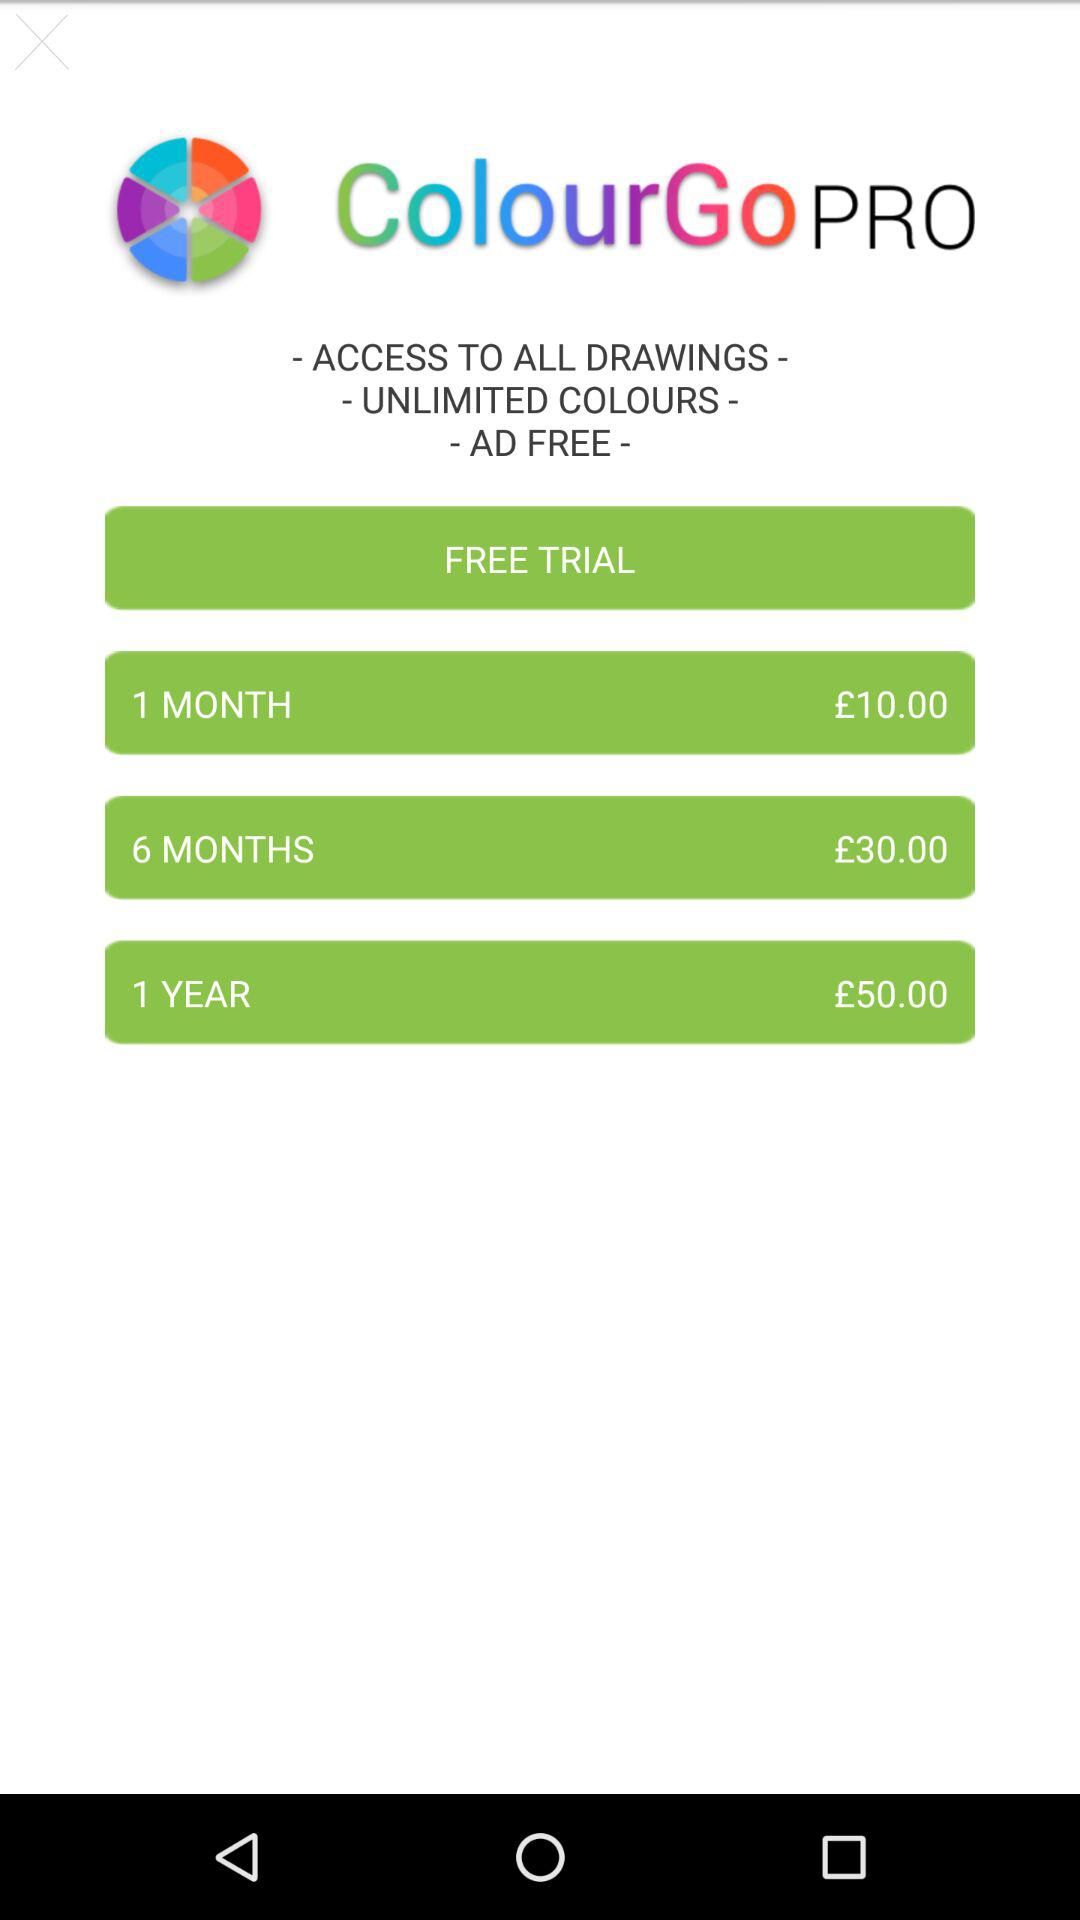How long is the free trial?
When the provided information is insufficient, respond with <no answer>. <no answer> 